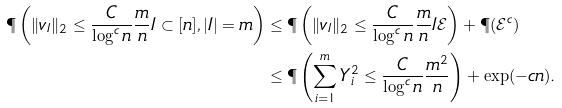<formula> <loc_0><loc_0><loc_500><loc_500>\P \left ( \| v _ { I } \| _ { 2 } \leq \frac { C } { \log ^ { c } n } \frac { m } { n } I \subset [ n ] , | I | = m \right ) & \leq \P \left ( \| v _ { I } \| _ { 2 } \leq \frac { C } { \log ^ { c } n } \frac { m } { n } I \mathcal { E } \right ) + \P ( \mathcal { E } ^ { c } ) \\ & \leq \P \left ( \sum _ { i = 1 } ^ { m } Y _ { i } ^ { 2 } \leq \frac { C } { \log ^ { c } n } \frac { m ^ { 2 } } { n } \right ) + \exp ( - c n ) .</formula> 